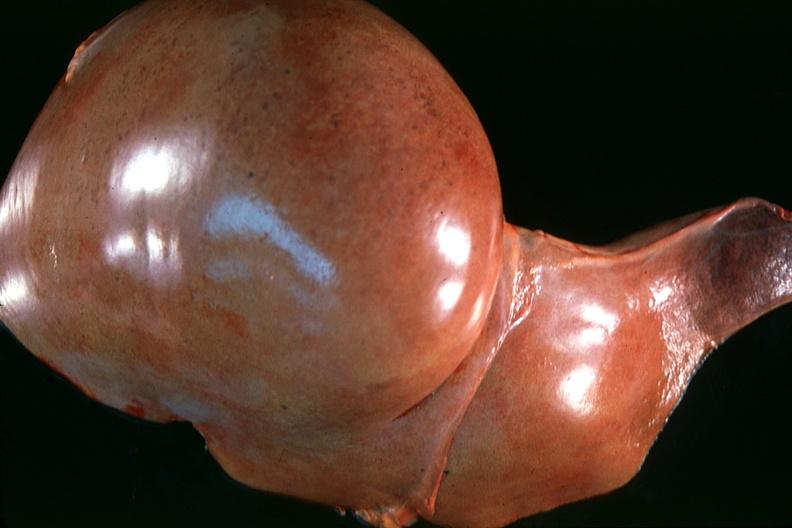does parathyroid show normal liver?
Answer the question using a single word or phrase. No 